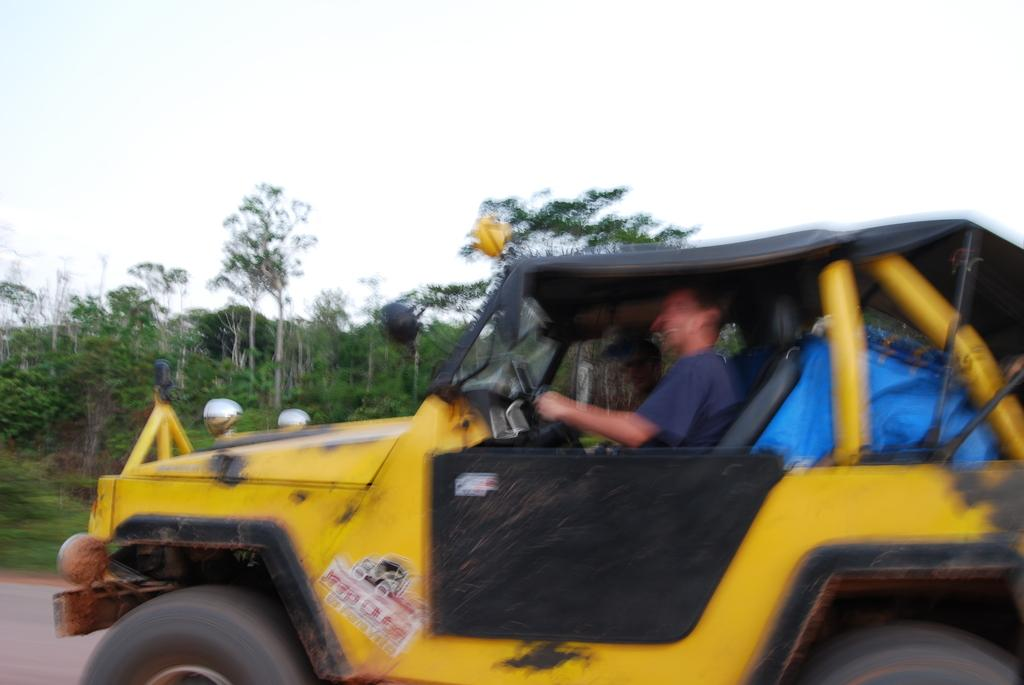Where was the image taken? The image is taken outdoors. What is the weather like in the image? It is sunny in the image. What are the two persons doing in the image? They are sitting on a vehicle. What color is the vehicle? The vehicle is yellow. What can be seen behind the vehicle? There are trees behind the vehicle. What is visible above the scene in the image? The sky is visible in the image. How many blades of grass can be seen in the image? There is no grass visible in the image; it is taken outdoors, but the focus is on the vehicle and the persons sitting on it. 